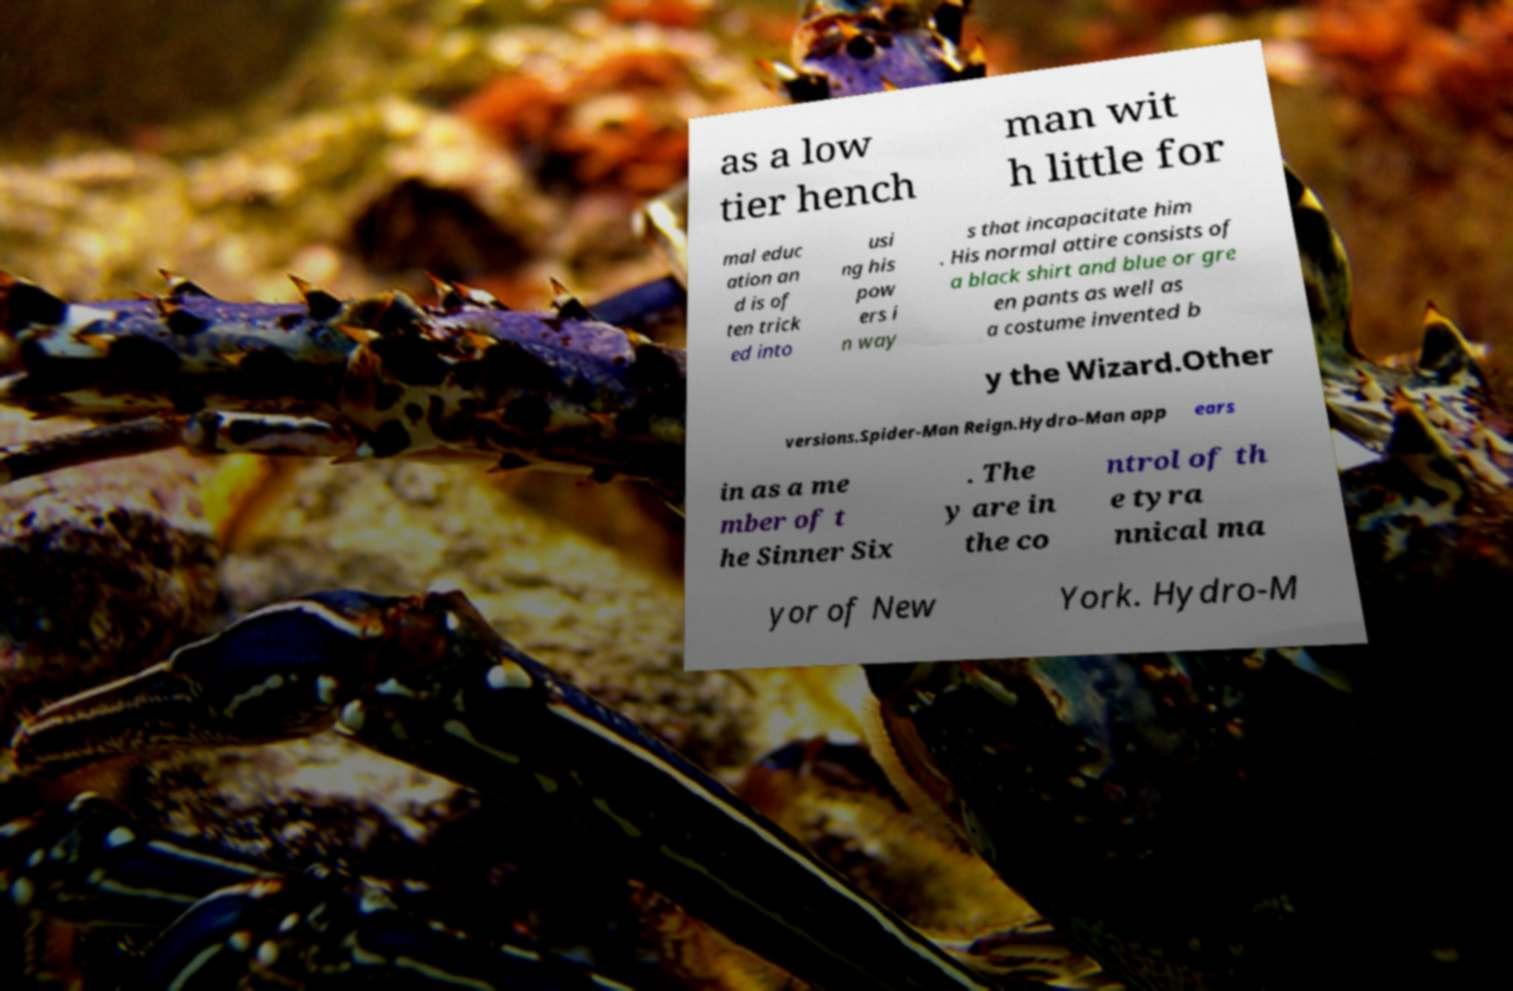There's text embedded in this image that I need extracted. Can you transcribe it verbatim? as a low tier hench man wit h little for mal educ ation an d is of ten trick ed into usi ng his pow ers i n way s that incapacitate him . His normal attire consists of a black shirt and blue or gre en pants as well as a costume invented b y the Wizard.Other versions.Spider-Man Reign.Hydro-Man app ears in as a me mber of t he Sinner Six . The y are in the co ntrol of th e tyra nnical ma yor of New York. Hydro-M 